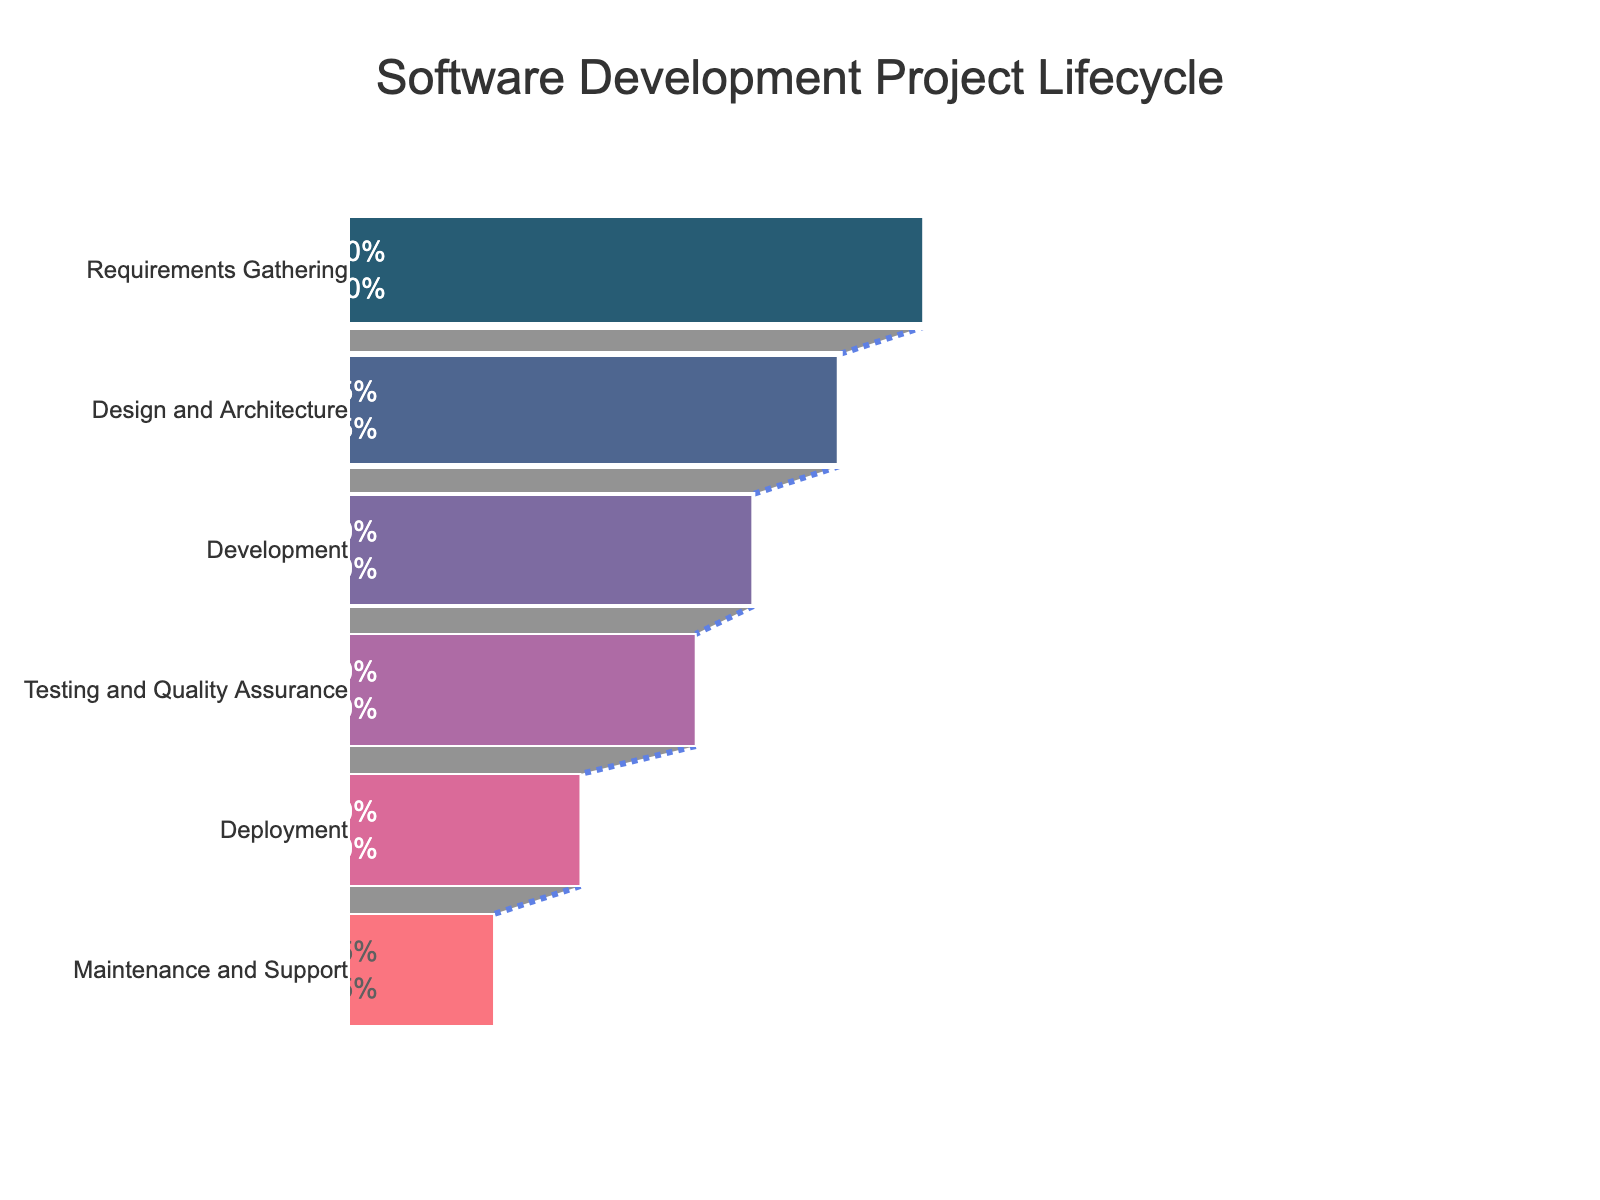What is the title of the funnel chart? The title is typically displayed at the top of the chart. It reads "Software Development Project Lifecycle."
Answer: "Software Development Project Lifecycle" How many stages are there in the software development lifecycle according to the chart? You can count the number of distinct stages listed on the y-axis of the funnel chart.
Answer: 6 What is the percentage of resources allocated to the Development stage? Locate the "Development" stage on the chart and refer to the x-axis value next to it, which represents the percentage of resources allocated.
Answer: 70% Which stage has the least resource allocation, and what is the percentage? Find the stage at the bottom of the funnel chart which has the shortest length on the x-axis. This stage is "Maintenance and Support," and the percentage is shown next to it.
Answer: Maintenance and Support, 25% How much more resources are allocated to Requirements Gathering compared to Deployment? Subtract the percentage of resources allocated to Deployment from the percentage allocated to Requirements Gathering.
Answer: 100% - 40% = 60% What is the total percentage of resources allocated to Testing and Quality Assurance and Maintenance and Support combined? Add the percentages for the "Testing and Quality Assurance" stage and the "Maintenance and Support" stage.
Answer: 60% + 25% = 85% Which stages have more than 50% resource allocation? Identify and list the stages that have their resource allocation percentages greater than 50% on the x-axis.
Answer: Requirements Gathering, Design and Architecture, Development, Testing and Quality Assurance Compare the resource allocation between the Design and Architecture stage and the Testing and Quality Assurance stage. Which stage has more resources, and by how much? Subtract the resource percentage of the Testing and Quality Assurance stage from that of the Design and Architecture stage to determine the difference.
Answer: Design and Architecture, 85% - 60% = 25% more If resources for the Maintenance and Support stage were increased by 10%, what would the new allocation be? Add 10% to the current percentage allocated to the Maintenance and Support stage.
Answer: 25% + 10% = 35% Explain the trend you observe in resource allocation as the project progresses through different stages. Observing the funnel shape where each successive stage sees a decrement in resource allocation. Starting from a high percentage at "Requirements Gathering" and gradually decreasing to the lowest at "Maintenance and Support." This indicates a resource reduction trend as the project moves forward.
Answer: Decreasing trend in resource allocation through stages 